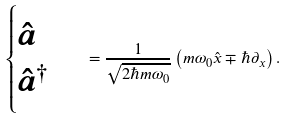Convert formula to latex. <formula><loc_0><loc_0><loc_500><loc_500>\begin{cases} \hat { a } \\ \hat { a } ^ { \dagger } \end{cases} = \frac { 1 } { \sqrt { 2 \hbar { m } \omega _ { 0 } } } \left ( m \omega _ { 0 } \hat { x } \mp \hbar { \partial } _ { x } \right ) .</formula> 